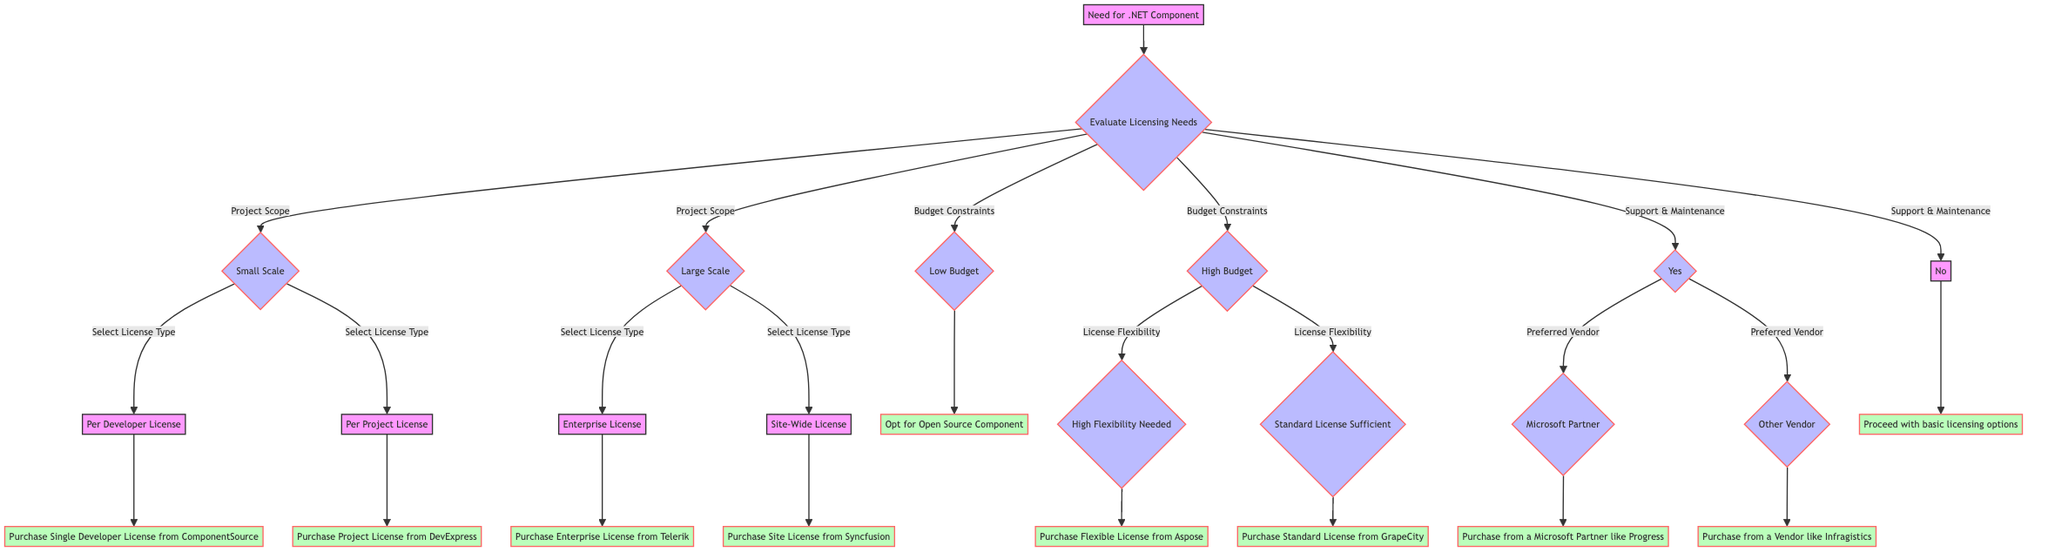What is the starting point of the decision tree? The starting point is represented by the node labeled "Need for .NET Component." This node is the first decision that leads into evaluating the licensing needs.
Answer: Need for .NET Component How many main evaluation criteria are there? The main evaluation criteria displayed in the diagram are "Project Scope," "Budget Constraints," and "Support & Maintenance." Each of these criteria leads to further deliberations.
Answer: Three What license type is chosen for small scale projects? For small scale projects, there are two license types indicated: "Per Developer License" and "Per Project License." Each of these options then leads to specific purchase actions.
Answer: Per Developer License or Per Project License If someone has a high budget and needs standard license flexibility, which outcome would they reach? In the case of having a high budget and choosing standard license flexibility, the outcome is to purchase the "Standard License from GrapeCity." This conclusion follows the decision-making path of "High Budget" leading to "Standard License Sufficient."
Answer: Purchase Standard License from GrapeCity What do you do if you have low budget constraints? If a customer has low budget constraints, they can opt for the "Open Source Component." This option is directly indicated as the outcome if low budget is selected under budget constraints.
Answer: Opt for Open Source Component Which outcome is achieved when support and maintenance are not needed? When support and maintenance are not needed, the path leads straight to the outcome "Proceed with basic licensing options." This is the direct result of not requiring additional support.
Answer: Proceed with basic licensing options What action is taken if a preferred vendor is a Microsoft Partner? If the preferred vendor is a Microsoft Partner, the action is to "Purchase from a Microsoft Partner like Progress." This occurs after selecting "Yes" for support & maintenance and then choosing "Microsoft Partner."
Answer: Purchase from a Microsoft Partner like Progress What two possible license types can be selected for large scale projects? For large scale projects, the two possible license types that can be selected are "Enterprise License" and "Site-Wide License." These options dictate the respective purchase actions that follow.
Answer: Enterprise License or Site-Wide License 